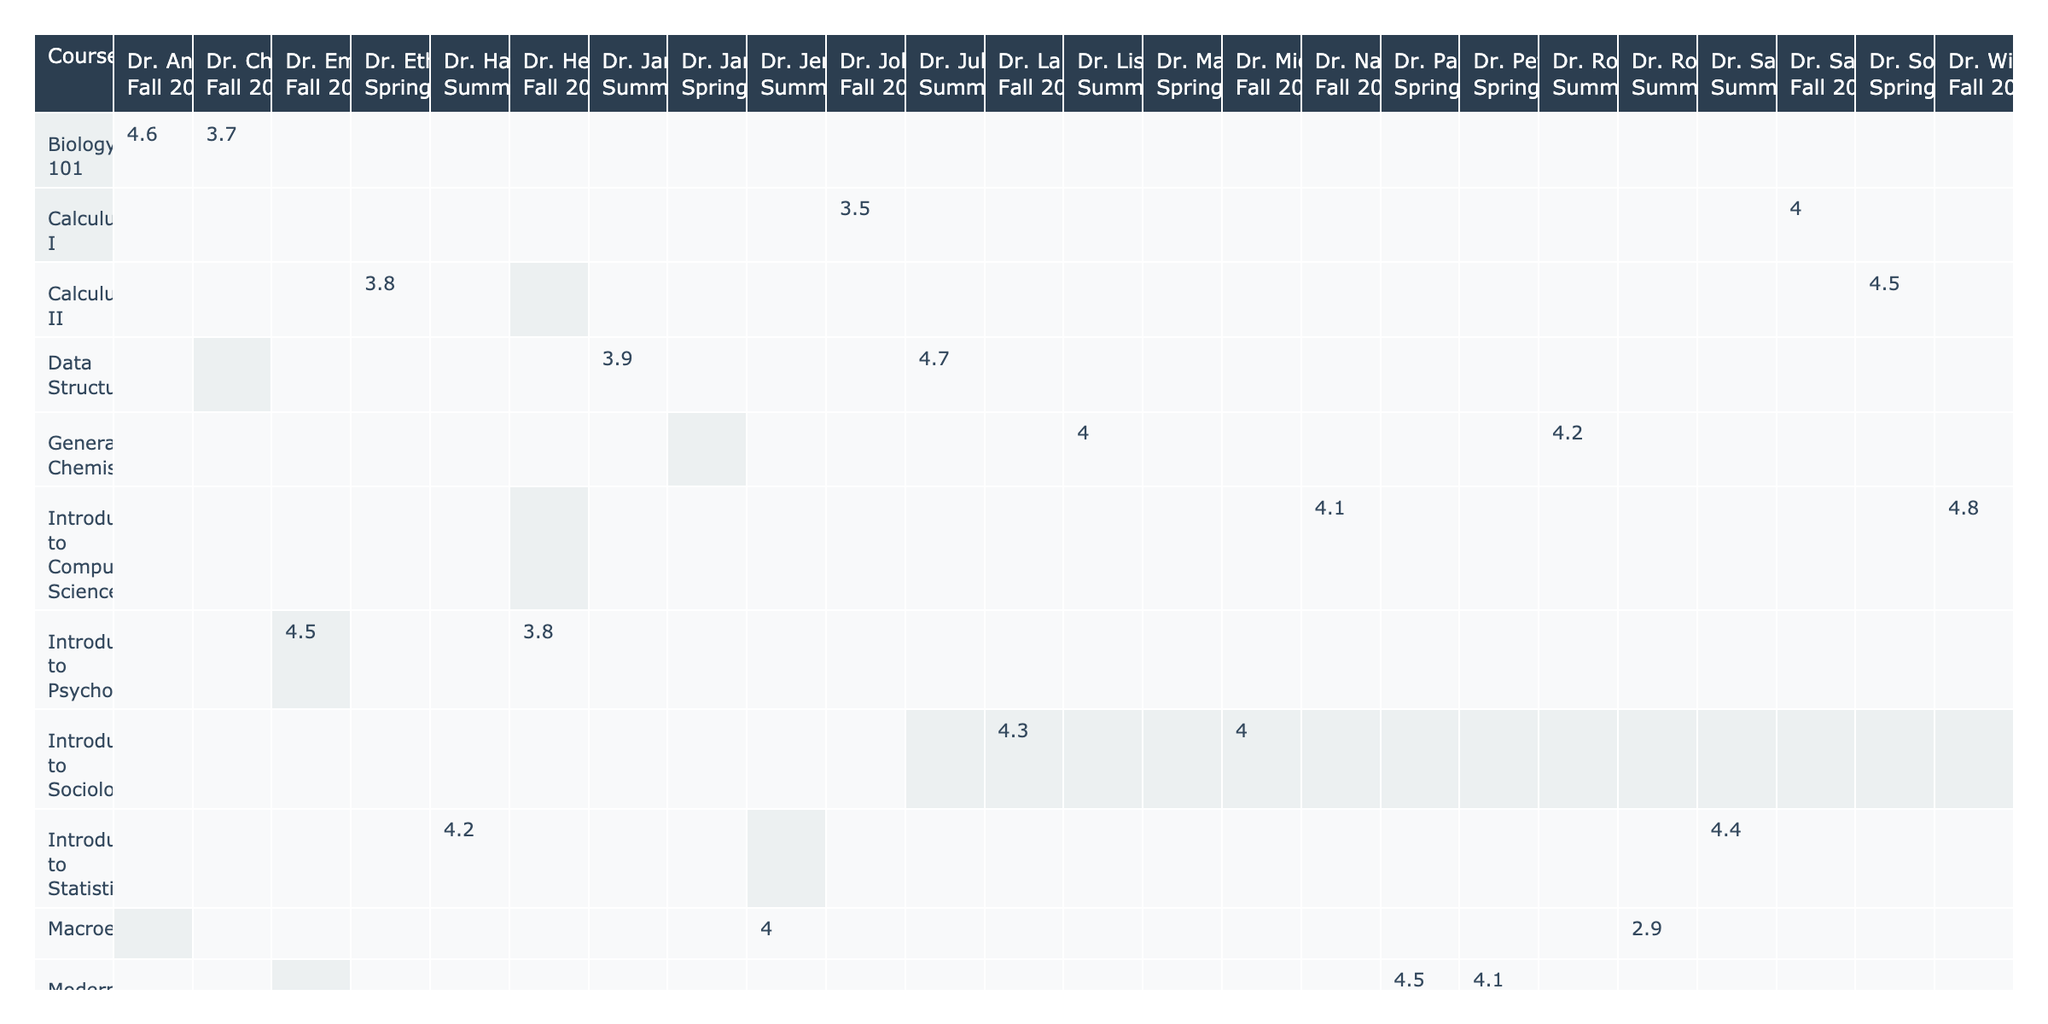What is the evaluation score for Dr. Emily Johnson in the Fall 2022 semester? The table shows that Dr. Emily Johnson taught "Introduction to Psychology" in the Fall 2022 semester with an evaluation score of 4.5.
Answer: 4.5 Which instructor received the lowest evaluation score for Macroeconomics? The table indicates that Dr. Robert Young received an evaluation score of 2.9 for Macroeconomics, making it the lowest score for this course.
Answer: Dr. Robert Young What is the average evaluation score for Calculus I? The scores for Calculus I are 4.0 and 3.5. The average is (4.0 + 3.5) / 2 = 3.75.
Answer: 3.75 Did Dr. Maria Garcia receive a higher score than Dr. James Wilson for Organic Chemistry? Dr. Maria Garcia received an evaluation score of 4.3 while Dr. James Wilson received 3.6, so the comparison shows that Dr. Maria Garcia had the higher score.
Answer: Yes Which instructor has the highest evaluation score overall, and what is that score? Looking through the scores in the table, Dr. William King received an evaluation score of 4.8 for Introduction to Computer Science, which is the highest score overall.
Answer: Dr. William King, 4.8 How many instructors received 4.0 or higher in the Spring 2023 semester? The instructors in Spring 2023 with scores of 4.0 or higher are Dr. Maria Garcia (4.3 for Organic Chemistry), Dr. Peter Clark (4.1 for Modern American History), and Dr. Patricia Evans (4.5 for Modern American History), totaling three instructors.
Answer: 3 What is the difference in evaluation scores between the highest and lowest for Introduction to Statistics? Dr. Samuel Nelson scored 4.4, while Dr. Hannah Lewis scored 4.2. Therefore, the difference is 4.4 - 4.2 = 0.2.
Answer: 0.2 In which semester did Introduction to Computer Science receive the highest score? The table shows that in Fall 2022, Introduction to Computer Science received its highest evaluation score of 4.8 from Dr. William King.
Answer: Fall 2022 What is the total number of evaluation scores recorded for Biology 101? The table indicates two scores for Biology 101: one from Dr. Angela Roberts and another from Dr. Charles Green. Therefore, the total number is 2.
Answer: 2 Who taught Introduction to Sociology with the highest evaluation score and what was that score? Dr. Laura Thompson taught Introduction to Sociology with a score of 4.3, which is higher than Dr. Michael Scott's score of 4.0. Thus, Dr. Laura Thompson is the instructor with the highest score.
Answer: Dr. Laura Thompson, 4.3 